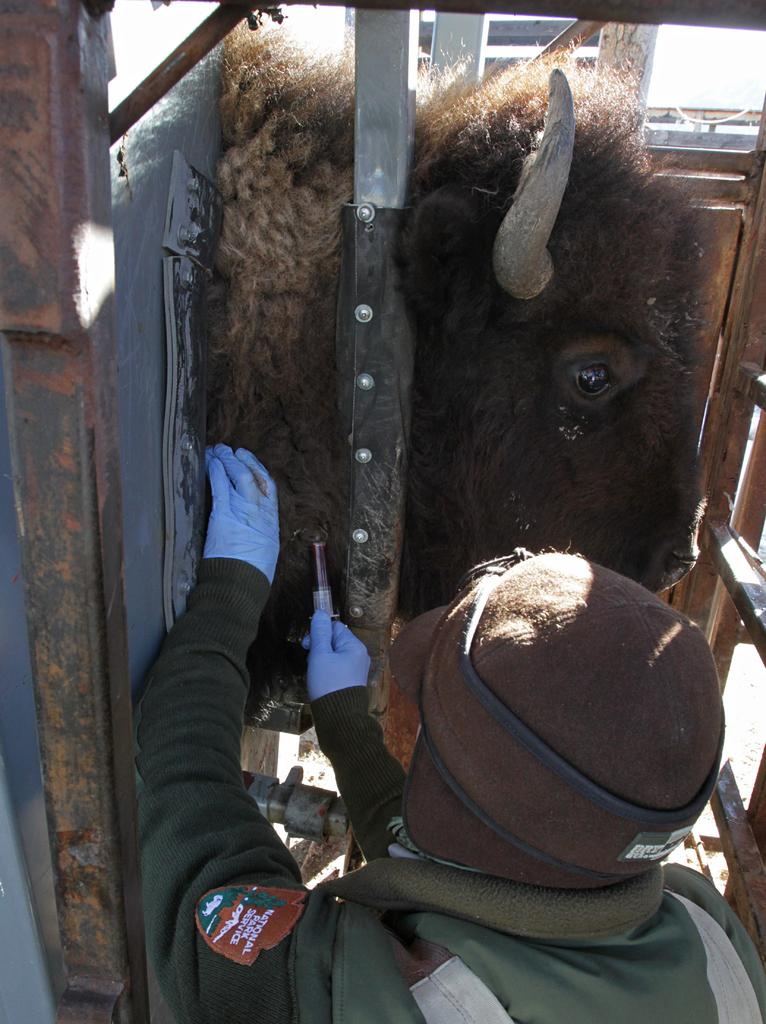Who or what is present in the image? There is a person and a yak in the image. What is the person holding in the image? The person is holding an unspecified object. What else can be seen in the image besides the person and the yak? There are rods in the image. What type of account does the yak have in the image? There is no mention of an account in the image. The image features a person, a yak, and some rods. --- Facts: 1. There is a person in the image. 2. The person is wearing a hat. 3. The person is holding a book. 4. There is a table in the image. 5. The table has a vase with flowers on it. Absurd Topics: ocean Conversation: Who or what is present in the image? There is a person in the image. What is the person wearing in the image? The person is wearing a hat in the image. What is the person holding in the image? The person is holding a book in the image. What else can be seen in the image besides the person? There is a table in the image. What is on the table in the image? There is a vase with flowers on it in the image. Reasoning: Let's think step by step in order to produce the conversation. We start by identifying the main subject in the image, which is the person. Then, we describe the person's attire, specifically mentioning the hat. Next, we focus on the object the person is holding, which is a book. After that, we mention the presence of a table in the image. Finally, we describe what is on the table, which is a vase with flowers on it. Absurd Question/Answer: Can you see the ocean in the image? No, the ocean is not present in the image. The image features a person, a hat, a book, a table, and a vase with flowers on it. 